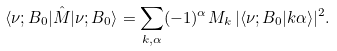<formula> <loc_0><loc_0><loc_500><loc_500>\langle \nu ; B _ { 0 } | \hat { M } | \nu ; B _ { 0 } \rangle = \sum _ { k , \alpha } ( - 1 ) ^ { \alpha } M _ { k } \, | \langle \nu ; B _ { 0 } | k \alpha \rangle | ^ { 2 } .</formula> 